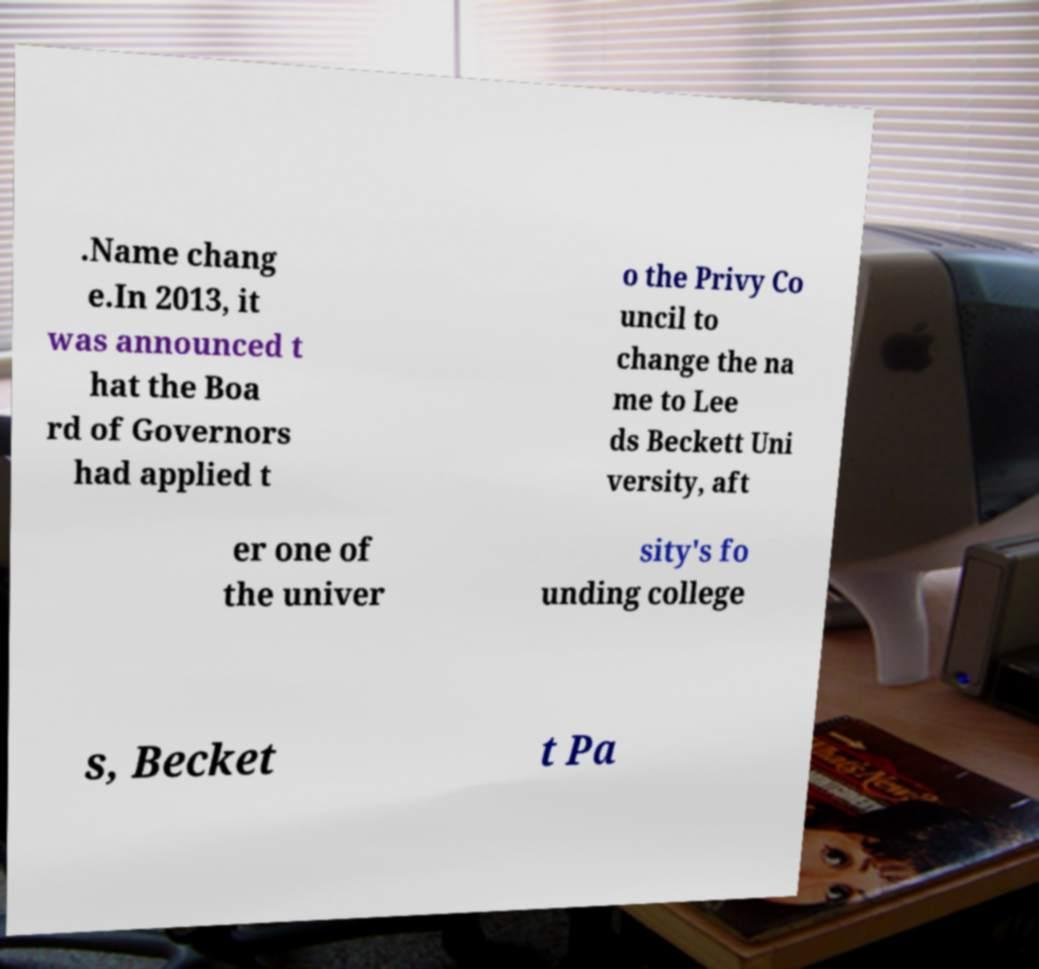Can you accurately transcribe the text from the provided image for me? .Name chang e.In 2013, it was announced t hat the Boa rd of Governors had applied t o the Privy Co uncil to change the na me to Lee ds Beckett Uni versity, aft er one of the univer sity's fo unding college s, Becket t Pa 